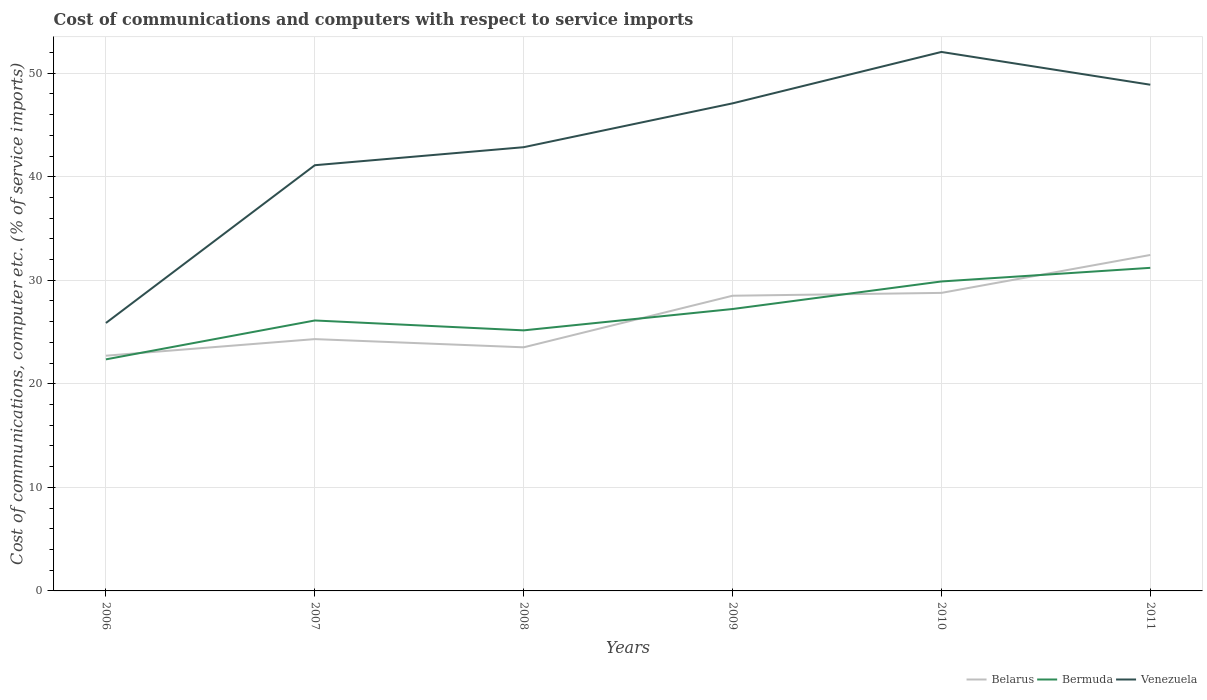Does the line corresponding to Venezuela intersect with the line corresponding to Bermuda?
Provide a short and direct response. No. Is the number of lines equal to the number of legend labels?
Ensure brevity in your answer.  Yes. Across all years, what is the maximum cost of communications and computers in Venezuela?
Give a very brief answer. 25.88. In which year was the cost of communications and computers in Bermuda maximum?
Provide a short and direct response. 2006. What is the total cost of communications and computers in Belarus in the graph?
Provide a short and direct response. -1.6. What is the difference between the highest and the second highest cost of communications and computers in Belarus?
Offer a very short reply. 9.73. What is the difference between the highest and the lowest cost of communications and computers in Venezuela?
Your answer should be compact. 3. How many lines are there?
Your answer should be very brief. 3. How many years are there in the graph?
Give a very brief answer. 6. What is the difference between two consecutive major ticks on the Y-axis?
Your response must be concise. 10. Does the graph contain grids?
Make the answer very short. Yes. Where does the legend appear in the graph?
Your response must be concise. Bottom right. What is the title of the graph?
Your answer should be compact. Cost of communications and computers with respect to service imports. What is the label or title of the X-axis?
Offer a very short reply. Years. What is the label or title of the Y-axis?
Offer a very short reply. Cost of communications, computer etc. (% of service imports). What is the Cost of communications, computer etc. (% of service imports) of Belarus in 2006?
Your answer should be very brief. 22.72. What is the Cost of communications, computer etc. (% of service imports) in Bermuda in 2006?
Your answer should be compact. 22.36. What is the Cost of communications, computer etc. (% of service imports) in Venezuela in 2006?
Your answer should be compact. 25.88. What is the Cost of communications, computer etc. (% of service imports) of Belarus in 2007?
Make the answer very short. 24.32. What is the Cost of communications, computer etc. (% of service imports) in Bermuda in 2007?
Give a very brief answer. 26.12. What is the Cost of communications, computer etc. (% of service imports) in Venezuela in 2007?
Provide a succinct answer. 41.11. What is the Cost of communications, computer etc. (% of service imports) in Belarus in 2008?
Offer a terse response. 23.53. What is the Cost of communications, computer etc. (% of service imports) in Bermuda in 2008?
Keep it short and to the point. 25.16. What is the Cost of communications, computer etc. (% of service imports) of Venezuela in 2008?
Make the answer very short. 42.85. What is the Cost of communications, computer etc. (% of service imports) in Belarus in 2009?
Keep it short and to the point. 28.51. What is the Cost of communications, computer etc. (% of service imports) of Bermuda in 2009?
Your answer should be compact. 27.22. What is the Cost of communications, computer etc. (% of service imports) of Venezuela in 2009?
Your answer should be very brief. 47.09. What is the Cost of communications, computer etc. (% of service imports) of Belarus in 2010?
Your response must be concise. 28.78. What is the Cost of communications, computer etc. (% of service imports) in Bermuda in 2010?
Keep it short and to the point. 29.89. What is the Cost of communications, computer etc. (% of service imports) of Venezuela in 2010?
Your answer should be compact. 52.05. What is the Cost of communications, computer etc. (% of service imports) in Belarus in 2011?
Keep it short and to the point. 32.44. What is the Cost of communications, computer etc. (% of service imports) in Bermuda in 2011?
Your response must be concise. 31.2. What is the Cost of communications, computer etc. (% of service imports) in Venezuela in 2011?
Make the answer very short. 48.89. Across all years, what is the maximum Cost of communications, computer etc. (% of service imports) in Belarus?
Your response must be concise. 32.44. Across all years, what is the maximum Cost of communications, computer etc. (% of service imports) in Bermuda?
Ensure brevity in your answer.  31.2. Across all years, what is the maximum Cost of communications, computer etc. (% of service imports) in Venezuela?
Your response must be concise. 52.05. Across all years, what is the minimum Cost of communications, computer etc. (% of service imports) in Belarus?
Your answer should be very brief. 22.72. Across all years, what is the minimum Cost of communications, computer etc. (% of service imports) in Bermuda?
Ensure brevity in your answer.  22.36. Across all years, what is the minimum Cost of communications, computer etc. (% of service imports) of Venezuela?
Your response must be concise. 25.88. What is the total Cost of communications, computer etc. (% of service imports) of Belarus in the graph?
Your answer should be very brief. 160.3. What is the total Cost of communications, computer etc. (% of service imports) of Bermuda in the graph?
Keep it short and to the point. 161.96. What is the total Cost of communications, computer etc. (% of service imports) in Venezuela in the graph?
Offer a terse response. 257.87. What is the difference between the Cost of communications, computer etc. (% of service imports) in Belarus in 2006 and that in 2007?
Your response must be concise. -1.6. What is the difference between the Cost of communications, computer etc. (% of service imports) in Bermuda in 2006 and that in 2007?
Your response must be concise. -3.76. What is the difference between the Cost of communications, computer etc. (% of service imports) in Venezuela in 2006 and that in 2007?
Your response must be concise. -15.24. What is the difference between the Cost of communications, computer etc. (% of service imports) of Belarus in 2006 and that in 2008?
Your answer should be compact. -0.81. What is the difference between the Cost of communications, computer etc. (% of service imports) in Bermuda in 2006 and that in 2008?
Keep it short and to the point. -2.8. What is the difference between the Cost of communications, computer etc. (% of service imports) of Venezuela in 2006 and that in 2008?
Your answer should be compact. -16.98. What is the difference between the Cost of communications, computer etc. (% of service imports) in Belarus in 2006 and that in 2009?
Keep it short and to the point. -5.79. What is the difference between the Cost of communications, computer etc. (% of service imports) of Bermuda in 2006 and that in 2009?
Make the answer very short. -4.86. What is the difference between the Cost of communications, computer etc. (% of service imports) in Venezuela in 2006 and that in 2009?
Make the answer very short. -21.21. What is the difference between the Cost of communications, computer etc. (% of service imports) of Belarus in 2006 and that in 2010?
Your response must be concise. -6.07. What is the difference between the Cost of communications, computer etc. (% of service imports) of Bermuda in 2006 and that in 2010?
Your answer should be very brief. -7.52. What is the difference between the Cost of communications, computer etc. (% of service imports) in Venezuela in 2006 and that in 2010?
Keep it short and to the point. -26.18. What is the difference between the Cost of communications, computer etc. (% of service imports) in Belarus in 2006 and that in 2011?
Your answer should be very brief. -9.73. What is the difference between the Cost of communications, computer etc. (% of service imports) of Bermuda in 2006 and that in 2011?
Offer a very short reply. -8.84. What is the difference between the Cost of communications, computer etc. (% of service imports) in Venezuela in 2006 and that in 2011?
Provide a succinct answer. -23.01. What is the difference between the Cost of communications, computer etc. (% of service imports) of Belarus in 2007 and that in 2008?
Your answer should be very brief. 0.79. What is the difference between the Cost of communications, computer etc. (% of service imports) of Bermuda in 2007 and that in 2008?
Your answer should be compact. 0.95. What is the difference between the Cost of communications, computer etc. (% of service imports) of Venezuela in 2007 and that in 2008?
Keep it short and to the point. -1.74. What is the difference between the Cost of communications, computer etc. (% of service imports) of Belarus in 2007 and that in 2009?
Offer a terse response. -4.19. What is the difference between the Cost of communications, computer etc. (% of service imports) of Bermuda in 2007 and that in 2009?
Give a very brief answer. -1.11. What is the difference between the Cost of communications, computer etc. (% of service imports) in Venezuela in 2007 and that in 2009?
Give a very brief answer. -5.97. What is the difference between the Cost of communications, computer etc. (% of service imports) of Belarus in 2007 and that in 2010?
Provide a succinct answer. -4.46. What is the difference between the Cost of communications, computer etc. (% of service imports) of Bermuda in 2007 and that in 2010?
Provide a short and direct response. -3.77. What is the difference between the Cost of communications, computer etc. (% of service imports) in Venezuela in 2007 and that in 2010?
Give a very brief answer. -10.94. What is the difference between the Cost of communications, computer etc. (% of service imports) of Belarus in 2007 and that in 2011?
Give a very brief answer. -8.13. What is the difference between the Cost of communications, computer etc. (% of service imports) in Bermuda in 2007 and that in 2011?
Your answer should be compact. -5.08. What is the difference between the Cost of communications, computer etc. (% of service imports) in Venezuela in 2007 and that in 2011?
Your answer should be very brief. -7.77. What is the difference between the Cost of communications, computer etc. (% of service imports) of Belarus in 2008 and that in 2009?
Offer a very short reply. -4.98. What is the difference between the Cost of communications, computer etc. (% of service imports) in Bermuda in 2008 and that in 2009?
Your answer should be very brief. -2.06. What is the difference between the Cost of communications, computer etc. (% of service imports) in Venezuela in 2008 and that in 2009?
Your answer should be very brief. -4.23. What is the difference between the Cost of communications, computer etc. (% of service imports) of Belarus in 2008 and that in 2010?
Offer a very short reply. -5.26. What is the difference between the Cost of communications, computer etc. (% of service imports) in Bermuda in 2008 and that in 2010?
Your response must be concise. -4.72. What is the difference between the Cost of communications, computer etc. (% of service imports) of Venezuela in 2008 and that in 2010?
Your response must be concise. -9.2. What is the difference between the Cost of communications, computer etc. (% of service imports) of Belarus in 2008 and that in 2011?
Your answer should be compact. -8.92. What is the difference between the Cost of communications, computer etc. (% of service imports) in Bermuda in 2008 and that in 2011?
Your answer should be very brief. -6.04. What is the difference between the Cost of communications, computer etc. (% of service imports) of Venezuela in 2008 and that in 2011?
Offer a very short reply. -6.03. What is the difference between the Cost of communications, computer etc. (% of service imports) in Belarus in 2009 and that in 2010?
Make the answer very short. -0.28. What is the difference between the Cost of communications, computer etc. (% of service imports) of Bermuda in 2009 and that in 2010?
Your answer should be very brief. -2.66. What is the difference between the Cost of communications, computer etc. (% of service imports) of Venezuela in 2009 and that in 2010?
Your answer should be compact. -4.96. What is the difference between the Cost of communications, computer etc. (% of service imports) of Belarus in 2009 and that in 2011?
Your answer should be compact. -3.94. What is the difference between the Cost of communications, computer etc. (% of service imports) of Bermuda in 2009 and that in 2011?
Give a very brief answer. -3.98. What is the difference between the Cost of communications, computer etc. (% of service imports) of Venezuela in 2009 and that in 2011?
Your answer should be compact. -1.8. What is the difference between the Cost of communications, computer etc. (% of service imports) in Belarus in 2010 and that in 2011?
Provide a short and direct response. -3.66. What is the difference between the Cost of communications, computer etc. (% of service imports) of Bermuda in 2010 and that in 2011?
Your answer should be compact. -1.32. What is the difference between the Cost of communications, computer etc. (% of service imports) in Venezuela in 2010 and that in 2011?
Your answer should be very brief. 3.16. What is the difference between the Cost of communications, computer etc. (% of service imports) of Belarus in 2006 and the Cost of communications, computer etc. (% of service imports) of Bermuda in 2007?
Offer a terse response. -3.4. What is the difference between the Cost of communications, computer etc. (% of service imports) in Belarus in 2006 and the Cost of communications, computer etc. (% of service imports) in Venezuela in 2007?
Provide a short and direct response. -18.4. What is the difference between the Cost of communications, computer etc. (% of service imports) of Bermuda in 2006 and the Cost of communications, computer etc. (% of service imports) of Venezuela in 2007?
Give a very brief answer. -18.75. What is the difference between the Cost of communications, computer etc. (% of service imports) of Belarus in 2006 and the Cost of communications, computer etc. (% of service imports) of Bermuda in 2008?
Offer a very short reply. -2.45. What is the difference between the Cost of communications, computer etc. (% of service imports) of Belarus in 2006 and the Cost of communications, computer etc. (% of service imports) of Venezuela in 2008?
Offer a terse response. -20.14. What is the difference between the Cost of communications, computer etc. (% of service imports) of Bermuda in 2006 and the Cost of communications, computer etc. (% of service imports) of Venezuela in 2008?
Ensure brevity in your answer.  -20.49. What is the difference between the Cost of communications, computer etc. (% of service imports) in Belarus in 2006 and the Cost of communications, computer etc. (% of service imports) in Bermuda in 2009?
Offer a very short reply. -4.51. What is the difference between the Cost of communications, computer etc. (% of service imports) in Belarus in 2006 and the Cost of communications, computer etc. (% of service imports) in Venezuela in 2009?
Provide a short and direct response. -24.37. What is the difference between the Cost of communications, computer etc. (% of service imports) in Bermuda in 2006 and the Cost of communications, computer etc. (% of service imports) in Venezuela in 2009?
Your answer should be very brief. -24.72. What is the difference between the Cost of communications, computer etc. (% of service imports) of Belarus in 2006 and the Cost of communications, computer etc. (% of service imports) of Bermuda in 2010?
Make the answer very short. -7.17. What is the difference between the Cost of communications, computer etc. (% of service imports) in Belarus in 2006 and the Cost of communications, computer etc. (% of service imports) in Venezuela in 2010?
Offer a very short reply. -29.34. What is the difference between the Cost of communications, computer etc. (% of service imports) of Bermuda in 2006 and the Cost of communications, computer etc. (% of service imports) of Venezuela in 2010?
Keep it short and to the point. -29.69. What is the difference between the Cost of communications, computer etc. (% of service imports) of Belarus in 2006 and the Cost of communications, computer etc. (% of service imports) of Bermuda in 2011?
Offer a terse response. -8.49. What is the difference between the Cost of communications, computer etc. (% of service imports) in Belarus in 2006 and the Cost of communications, computer etc. (% of service imports) in Venezuela in 2011?
Offer a terse response. -26.17. What is the difference between the Cost of communications, computer etc. (% of service imports) of Bermuda in 2006 and the Cost of communications, computer etc. (% of service imports) of Venezuela in 2011?
Your answer should be very brief. -26.52. What is the difference between the Cost of communications, computer etc. (% of service imports) of Belarus in 2007 and the Cost of communications, computer etc. (% of service imports) of Bermuda in 2008?
Provide a succinct answer. -0.84. What is the difference between the Cost of communications, computer etc. (% of service imports) of Belarus in 2007 and the Cost of communications, computer etc. (% of service imports) of Venezuela in 2008?
Make the answer very short. -18.53. What is the difference between the Cost of communications, computer etc. (% of service imports) in Bermuda in 2007 and the Cost of communications, computer etc. (% of service imports) in Venezuela in 2008?
Make the answer very short. -16.73. What is the difference between the Cost of communications, computer etc. (% of service imports) in Belarus in 2007 and the Cost of communications, computer etc. (% of service imports) in Bermuda in 2009?
Your response must be concise. -2.91. What is the difference between the Cost of communications, computer etc. (% of service imports) in Belarus in 2007 and the Cost of communications, computer etc. (% of service imports) in Venezuela in 2009?
Provide a short and direct response. -22.77. What is the difference between the Cost of communications, computer etc. (% of service imports) of Bermuda in 2007 and the Cost of communications, computer etc. (% of service imports) of Venezuela in 2009?
Offer a terse response. -20.97. What is the difference between the Cost of communications, computer etc. (% of service imports) of Belarus in 2007 and the Cost of communications, computer etc. (% of service imports) of Bermuda in 2010?
Provide a succinct answer. -5.57. What is the difference between the Cost of communications, computer etc. (% of service imports) of Belarus in 2007 and the Cost of communications, computer etc. (% of service imports) of Venezuela in 2010?
Make the answer very short. -27.73. What is the difference between the Cost of communications, computer etc. (% of service imports) of Bermuda in 2007 and the Cost of communications, computer etc. (% of service imports) of Venezuela in 2010?
Make the answer very short. -25.93. What is the difference between the Cost of communications, computer etc. (% of service imports) in Belarus in 2007 and the Cost of communications, computer etc. (% of service imports) in Bermuda in 2011?
Your answer should be very brief. -6.88. What is the difference between the Cost of communications, computer etc. (% of service imports) in Belarus in 2007 and the Cost of communications, computer etc. (% of service imports) in Venezuela in 2011?
Keep it short and to the point. -24.57. What is the difference between the Cost of communications, computer etc. (% of service imports) of Bermuda in 2007 and the Cost of communications, computer etc. (% of service imports) of Venezuela in 2011?
Ensure brevity in your answer.  -22.77. What is the difference between the Cost of communications, computer etc. (% of service imports) in Belarus in 2008 and the Cost of communications, computer etc. (% of service imports) in Bermuda in 2009?
Keep it short and to the point. -3.7. What is the difference between the Cost of communications, computer etc. (% of service imports) in Belarus in 2008 and the Cost of communications, computer etc. (% of service imports) in Venezuela in 2009?
Keep it short and to the point. -23.56. What is the difference between the Cost of communications, computer etc. (% of service imports) in Bermuda in 2008 and the Cost of communications, computer etc. (% of service imports) in Venezuela in 2009?
Keep it short and to the point. -21.92. What is the difference between the Cost of communications, computer etc. (% of service imports) in Belarus in 2008 and the Cost of communications, computer etc. (% of service imports) in Bermuda in 2010?
Your answer should be compact. -6.36. What is the difference between the Cost of communications, computer etc. (% of service imports) of Belarus in 2008 and the Cost of communications, computer etc. (% of service imports) of Venezuela in 2010?
Keep it short and to the point. -28.53. What is the difference between the Cost of communications, computer etc. (% of service imports) in Bermuda in 2008 and the Cost of communications, computer etc. (% of service imports) in Venezuela in 2010?
Offer a terse response. -26.89. What is the difference between the Cost of communications, computer etc. (% of service imports) in Belarus in 2008 and the Cost of communications, computer etc. (% of service imports) in Bermuda in 2011?
Offer a very short reply. -7.68. What is the difference between the Cost of communications, computer etc. (% of service imports) of Belarus in 2008 and the Cost of communications, computer etc. (% of service imports) of Venezuela in 2011?
Your answer should be compact. -25.36. What is the difference between the Cost of communications, computer etc. (% of service imports) of Bermuda in 2008 and the Cost of communications, computer etc. (% of service imports) of Venezuela in 2011?
Keep it short and to the point. -23.72. What is the difference between the Cost of communications, computer etc. (% of service imports) in Belarus in 2009 and the Cost of communications, computer etc. (% of service imports) in Bermuda in 2010?
Your answer should be compact. -1.38. What is the difference between the Cost of communications, computer etc. (% of service imports) in Belarus in 2009 and the Cost of communications, computer etc. (% of service imports) in Venezuela in 2010?
Provide a succinct answer. -23.54. What is the difference between the Cost of communications, computer etc. (% of service imports) in Bermuda in 2009 and the Cost of communications, computer etc. (% of service imports) in Venezuela in 2010?
Your answer should be compact. -24.83. What is the difference between the Cost of communications, computer etc. (% of service imports) of Belarus in 2009 and the Cost of communications, computer etc. (% of service imports) of Bermuda in 2011?
Keep it short and to the point. -2.69. What is the difference between the Cost of communications, computer etc. (% of service imports) in Belarus in 2009 and the Cost of communications, computer etc. (% of service imports) in Venezuela in 2011?
Give a very brief answer. -20.38. What is the difference between the Cost of communications, computer etc. (% of service imports) of Bermuda in 2009 and the Cost of communications, computer etc. (% of service imports) of Venezuela in 2011?
Offer a terse response. -21.66. What is the difference between the Cost of communications, computer etc. (% of service imports) of Belarus in 2010 and the Cost of communications, computer etc. (% of service imports) of Bermuda in 2011?
Offer a very short reply. -2.42. What is the difference between the Cost of communications, computer etc. (% of service imports) in Belarus in 2010 and the Cost of communications, computer etc. (% of service imports) in Venezuela in 2011?
Offer a terse response. -20.1. What is the difference between the Cost of communications, computer etc. (% of service imports) of Bermuda in 2010 and the Cost of communications, computer etc. (% of service imports) of Venezuela in 2011?
Your answer should be very brief. -19. What is the average Cost of communications, computer etc. (% of service imports) of Belarus per year?
Provide a succinct answer. 26.72. What is the average Cost of communications, computer etc. (% of service imports) of Bermuda per year?
Your answer should be very brief. 26.99. What is the average Cost of communications, computer etc. (% of service imports) in Venezuela per year?
Your answer should be very brief. 42.98. In the year 2006, what is the difference between the Cost of communications, computer etc. (% of service imports) in Belarus and Cost of communications, computer etc. (% of service imports) in Bermuda?
Provide a succinct answer. 0.35. In the year 2006, what is the difference between the Cost of communications, computer etc. (% of service imports) of Belarus and Cost of communications, computer etc. (% of service imports) of Venezuela?
Ensure brevity in your answer.  -3.16. In the year 2006, what is the difference between the Cost of communications, computer etc. (% of service imports) of Bermuda and Cost of communications, computer etc. (% of service imports) of Venezuela?
Your answer should be compact. -3.51. In the year 2007, what is the difference between the Cost of communications, computer etc. (% of service imports) in Belarus and Cost of communications, computer etc. (% of service imports) in Bermuda?
Offer a very short reply. -1.8. In the year 2007, what is the difference between the Cost of communications, computer etc. (% of service imports) of Belarus and Cost of communications, computer etc. (% of service imports) of Venezuela?
Offer a terse response. -16.79. In the year 2007, what is the difference between the Cost of communications, computer etc. (% of service imports) in Bermuda and Cost of communications, computer etc. (% of service imports) in Venezuela?
Your response must be concise. -14.99. In the year 2008, what is the difference between the Cost of communications, computer etc. (% of service imports) in Belarus and Cost of communications, computer etc. (% of service imports) in Bermuda?
Provide a succinct answer. -1.64. In the year 2008, what is the difference between the Cost of communications, computer etc. (% of service imports) in Belarus and Cost of communications, computer etc. (% of service imports) in Venezuela?
Your answer should be very brief. -19.33. In the year 2008, what is the difference between the Cost of communications, computer etc. (% of service imports) in Bermuda and Cost of communications, computer etc. (% of service imports) in Venezuela?
Keep it short and to the point. -17.69. In the year 2009, what is the difference between the Cost of communications, computer etc. (% of service imports) of Belarus and Cost of communications, computer etc. (% of service imports) of Bermuda?
Offer a very short reply. 1.28. In the year 2009, what is the difference between the Cost of communications, computer etc. (% of service imports) in Belarus and Cost of communications, computer etc. (% of service imports) in Venezuela?
Offer a terse response. -18.58. In the year 2009, what is the difference between the Cost of communications, computer etc. (% of service imports) of Bermuda and Cost of communications, computer etc. (% of service imports) of Venezuela?
Offer a terse response. -19.86. In the year 2010, what is the difference between the Cost of communications, computer etc. (% of service imports) of Belarus and Cost of communications, computer etc. (% of service imports) of Bermuda?
Your response must be concise. -1.1. In the year 2010, what is the difference between the Cost of communications, computer etc. (% of service imports) of Belarus and Cost of communications, computer etc. (% of service imports) of Venezuela?
Your answer should be compact. -23.27. In the year 2010, what is the difference between the Cost of communications, computer etc. (% of service imports) of Bermuda and Cost of communications, computer etc. (% of service imports) of Venezuela?
Ensure brevity in your answer.  -22.17. In the year 2011, what is the difference between the Cost of communications, computer etc. (% of service imports) of Belarus and Cost of communications, computer etc. (% of service imports) of Bermuda?
Offer a very short reply. 1.24. In the year 2011, what is the difference between the Cost of communications, computer etc. (% of service imports) of Belarus and Cost of communications, computer etc. (% of service imports) of Venezuela?
Offer a very short reply. -16.44. In the year 2011, what is the difference between the Cost of communications, computer etc. (% of service imports) in Bermuda and Cost of communications, computer etc. (% of service imports) in Venezuela?
Provide a succinct answer. -17.68. What is the ratio of the Cost of communications, computer etc. (% of service imports) in Belarus in 2006 to that in 2007?
Offer a very short reply. 0.93. What is the ratio of the Cost of communications, computer etc. (% of service imports) of Bermuda in 2006 to that in 2007?
Offer a very short reply. 0.86. What is the ratio of the Cost of communications, computer etc. (% of service imports) of Venezuela in 2006 to that in 2007?
Ensure brevity in your answer.  0.63. What is the ratio of the Cost of communications, computer etc. (% of service imports) in Belarus in 2006 to that in 2008?
Your answer should be very brief. 0.97. What is the ratio of the Cost of communications, computer etc. (% of service imports) in Bermuda in 2006 to that in 2008?
Offer a terse response. 0.89. What is the ratio of the Cost of communications, computer etc. (% of service imports) of Venezuela in 2006 to that in 2008?
Make the answer very short. 0.6. What is the ratio of the Cost of communications, computer etc. (% of service imports) in Belarus in 2006 to that in 2009?
Your response must be concise. 0.8. What is the ratio of the Cost of communications, computer etc. (% of service imports) in Bermuda in 2006 to that in 2009?
Make the answer very short. 0.82. What is the ratio of the Cost of communications, computer etc. (% of service imports) in Venezuela in 2006 to that in 2009?
Offer a terse response. 0.55. What is the ratio of the Cost of communications, computer etc. (% of service imports) of Belarus in 2006 to that in 2010?
Offer a very short reply. 0.79. What is the ratio of the Cost of communications, computer etc. (% of service imports) in Bermuda in 2006 to that in 2010?
Keep it short and to the point. 0.75. What is the ratio of the Cost of communications, computer etc. (% of service imports) of Venezuela in 2006 to that in 2010?
Your answer should be very brief. 0.5. What is the ratio of the Cost of communications, computer etc. (% of service imports) in Belarus in 2006 to that in 2011?
Your response must be concise. 0.7. What is the ratio of the Cost of communications, computer etc. (% of service imports) of Bermuda in 2006 to that in 2011?
Give a very brief answer. 0.72. What is the ratio of the Cost of communications, computer etc. (% of service imports) of Venezuela in 2006 to that in 2011?
Provide a short and direct response. 0.53. What is the ratio of the Cost of communications, computer etc. (% of service imports) of Belarus in 2007 to that in 2008?
Give a very brief answer. 1.03. What is the ratio of the Cost of communications, computer etc. (% of service imports) in Bermuda in 2007 to that in 2008?
Your response must be concise. 1.04. What is the ratio of the Cost of communications, computer etc. (% of service imports) of Venezuela in 2007 to that in 2008?
Provide a short and direct response. 0.96. What is the ratio of the Cost of communications, computer etc. (% of service imports) of Belarus in 2007 to that in 2009?
Ensure brevity in your answer.  0.85. What is the ratio of the Cost of communications, computer etc. (% of service imports) of Bermuda in 2007 to that in 2009?
Provide a short and direct response. 0.96. What is the ratio of the Cost of communications, computer etc. (% of service imports) in Venezuela in 2007 to that in 2009?
Your response must be concise. 0.87. What is the ratio of the Cost of communications, computer etc. (% of service imports) in Belarus in 2007 to that in 2010?
Give a very brief answer. 0.84. What is the ratio of the Cost of communications, computer etc. (% of service imports) in Bermuda in 2007 to that in 2010?
Your answer should be compact. 0.87. What is the ratio of the Cost of communications, computer etc. (% of service imports) of Venezuela in 2007 to that in 2010?
Provide a short and direct response. 0.79. What is the ratio of the Cost of communications, computer etc. (% of service imports) of Belarus in 2007 to that in 2011?
Provide a short and direct response. 0.75. What is the ratio of the Cost of communications, computer etc. (% of service imports) in Bermuda in 2007 to that in 2011?
Keep it short and to the point. 0.84. What is the ratio of the Cost of communications, computer etc. (% of service imports) in Venezuela in 2007 to that in 2011?
Ensure brevity in your answer.  0.84. What is the ratio of the Cost of communications, computer etc. (% of service imports) of Belarus in 2008 to that in 2009?
Your answer should be compact. 0.83. What is the ratio of the Cost of communications, computer etc. (% of service imports) in Bermuda in 2008 to that in 2009?
Your answer should be compact. 0.92. What is the ratio of the Cost of communications, computer etc. (% of service imports) of Venezuela in 2008 to that in 2009?
Your answer should be very brief. 0.91. What is the ratio of the Cost of communications, computer etc. (% of service imports) of Belarus in 2008 to that in 2010?
Offer a terse response. 0.82. What is the ratio of the Cost of communications, computer etc. (% of service imports) in Bermuda in 2008 to that in 2010?
Keep it short and to the point. 0.84. What is the ratio of the Cost of communications, computer etc. (% of service imports) in Venezuela in 2008 to that in 2010?
Make the answer very short. 0.82. What is the ratio of the Cost of communications, computer etc. (% of service imports) of Belarus in 2008 to that in 2011?
Give a very brief answer. 0.73. What is the ratio of the Cost of communications, computer etc. (% of service imports) of Bermuda in 2008 to that in 2011?
Provide a short and direct response. 0.81. What is the ratio of the Cost of communications, computer etc. (% of service imports) in Venezuela in 2008 to that in 2011?
Provide a short and direct response. 0.88. What is the ratio of the Cost of communications, computer etc. (% of service imports) of Bermuda in 2009 to that in 2010?
Keep it short and to the point. 0.91. What is the ratio of the Cost of communications, computer etc. (% of service imports) in Venezuela in 2009 to that in 2010?
Make the answer very short. 0.9. What is the ratio of the Cost of communications, computer etc. (% of service imports) of Belarus in 2009 to that in 2011?
Offer a terse response. 0.88. What is the ratio of the Cost of communications, computer etc. (% of service imports) in Bermuda in 2009 to that in 2011?
Provide a succinct answer. 0.87. What is the ratio of the Cost of communications, computer etc. (% of service imports) in Venezuela in 2009 to that in 2011?
Offer a terse response. 0.96. What is the ratio of the Cost of communications, computer etc. (% of service imports) in Belarus in 2010 to that in 2011?
Your answer should be compact. 0.89. What is the ratio of the Cost of communications, computer etc. (% of service imports) in Bermuda in 2010 to that in 2011?
Provide a short and direct response. 0.96. What is the ratio of the Cost of communications, computer etc. (% of service imports) in Venezuela in 2010 to that in 2011?
Provide a short and direct response. 1.06. What is the difference between the highest and the second highest Cost of communications, computer etc. (% of service imports) of Belarus?
Offer a terse response. 3.66. What is the difference between the highest and the second highest Cost of communications, computer etc. (% of service imports) in Bermuda?
Give a very brief answer. 1.32. What is the difference between the highest and the second highest Cost of communications, computer etc. (% of service imports) of Venezuela?
Make the answer very short. 3.16. What is the difference between the highest and the lowest Cost of communications, computer etc. (% of service imports) in Belarus?
Provide a short and direct response. 9.73. What is the difference between the highest and the lowest Cost of communications, computer etc. (% of service imports) in Bermuda?
Your response must be concise. 8.84. What is the difference between the highest and the lowest Cost of communications, computer etc. (% of service imports) in Venezuela?
Offer a terse response. 26.18. 